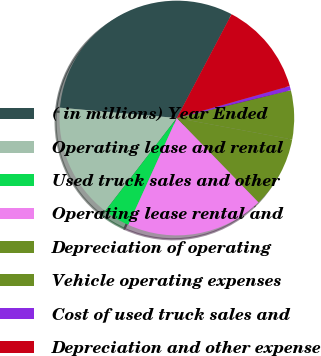<chart> <loc_0><loc_0><loc_500><loc_500><pie_chart><fcel>( in millions) Year Ended<fcel>Operating lease and rental<fcel>Used truck sales and other<fcel>Operating lease rental and<fcel>Depreciation of operating<fcel>Vehicle operating expenses<fcel>Cost of used truck sales and<fcel>Depreciation and other expense<nl><fcel>31.32%<fcel>15.96%<fcel>3.67%<fcel>19.03%<fcel>9.81%<fcel>6.74%<fcel>0.59%<fcel>12.88%<nl></chart> 